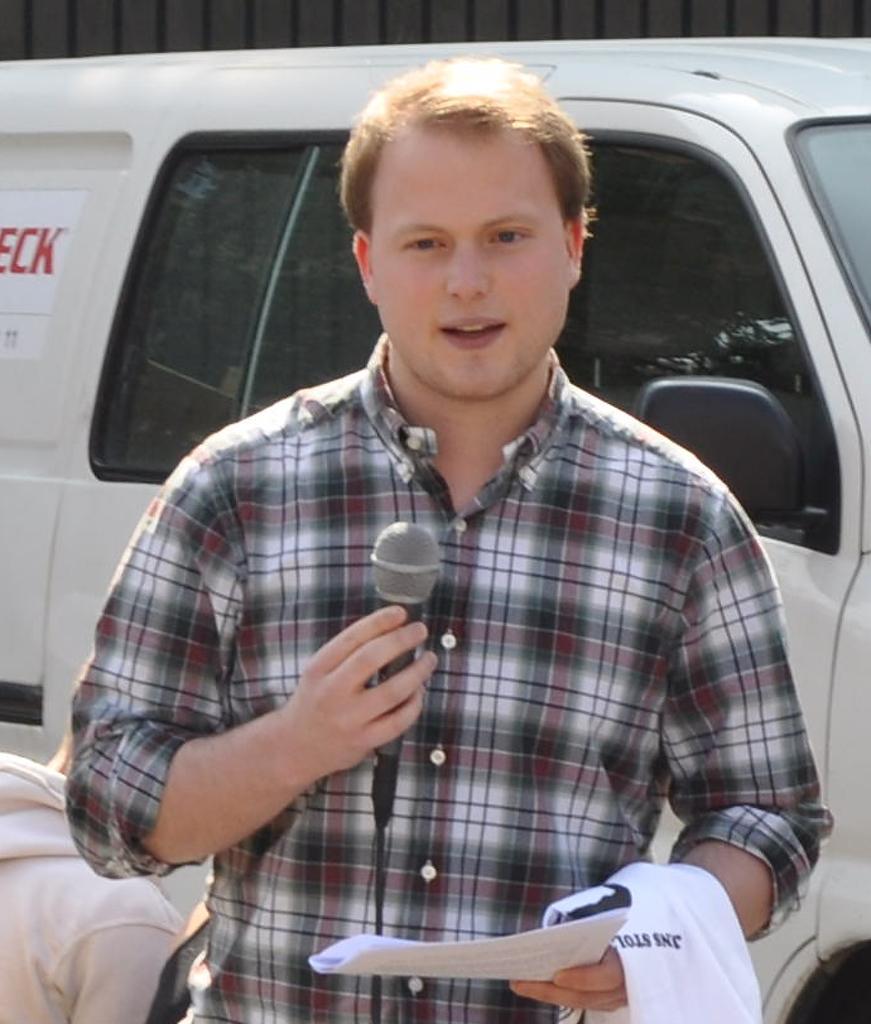Could you give a brief overview of what you see in this image? In this picture we can see a man holding papers and a microphone. Behind the man, there is a vehicle. At the top of the image, it looks like a wall. In the bottom left corner of the image, there is another person. 